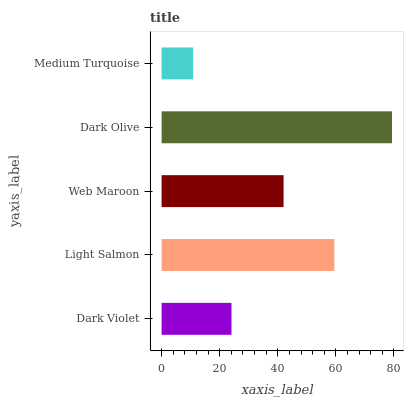Is Medium Turquoise the minimum?
Answer yes or no. Yes. Is Dark Olive the maximum?
Answer yes or no. Yes. Is Light Salmon the minimum?
Answer yes or no. No. Is Light Salmon the maximum?
Answer yes or no. No. Is Light Salmon greater than Dark Violet?
Answer yes or no. Yes. Is Dark Violet less than Light Salmon?
Answer yes or no. Yes. Is Dark Violet greater than Light Salmon?
Answer yes or no. No. Is Light Salmon less than Dark Violet?
Answer yes or no. No. Is Web Maroon the high median?
Answer yes or no. Yes. Is Web Maroon the low median?
Answer yes or no. Yes. Is Light Salmon the high median?
Answer yes or no. No. Is Dark Violet the low median?
Answer yes or no. No. 